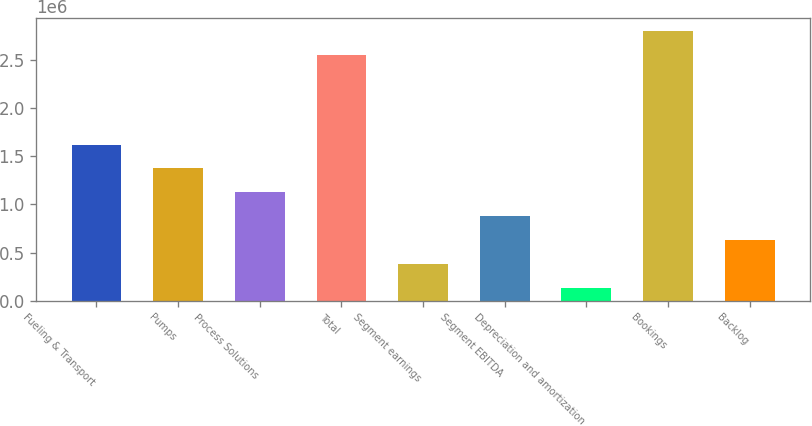Convert chart to OTSL. <chart><loc_0><loc_0><loc_500><loc_500><bar_chart><fcel>Fueling & Transport<fcel>Pumps<fcel>Process Solutions<fcel>Total<fcel>Segment earnings<fcel>Segment EBITDA<fcel>Depreciation and amortization<fcel>Bookings<fcel>Backlog<nl><fcel>1.62199e+06<fcel>1.37429e+06<fcel>1.1266e+06<fcel>2.55506e+06<fcel>383515<fcel>878904<fcel>135821<fcel>2.80276e+06<fcel>631209<nl></chart> 